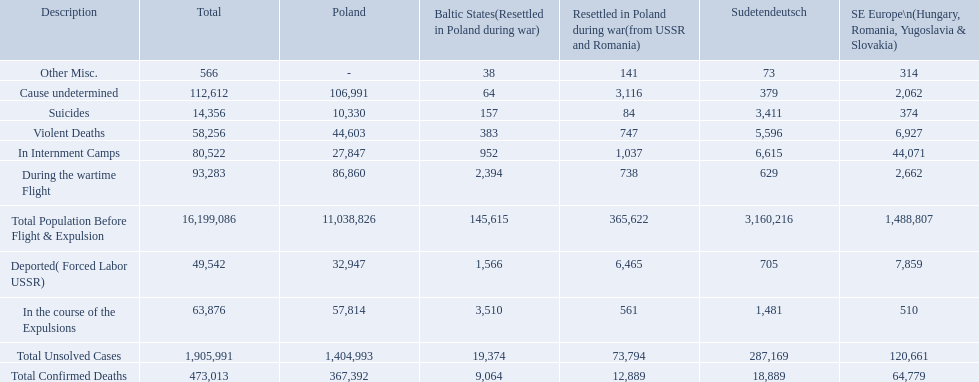How many deaths did the baltic states have in each category? 145,615, 383, 157, 1,566, 952, 2,394, 3,510, 64, 38, 9,064, 19,374. How many cause undetermined deaths did baltic states have? 64. How many other miscellaneous deaths did baltic states have? 38. Which is higher in deaths, cause undetermined or other miscellaneous? Cause undetermined. 